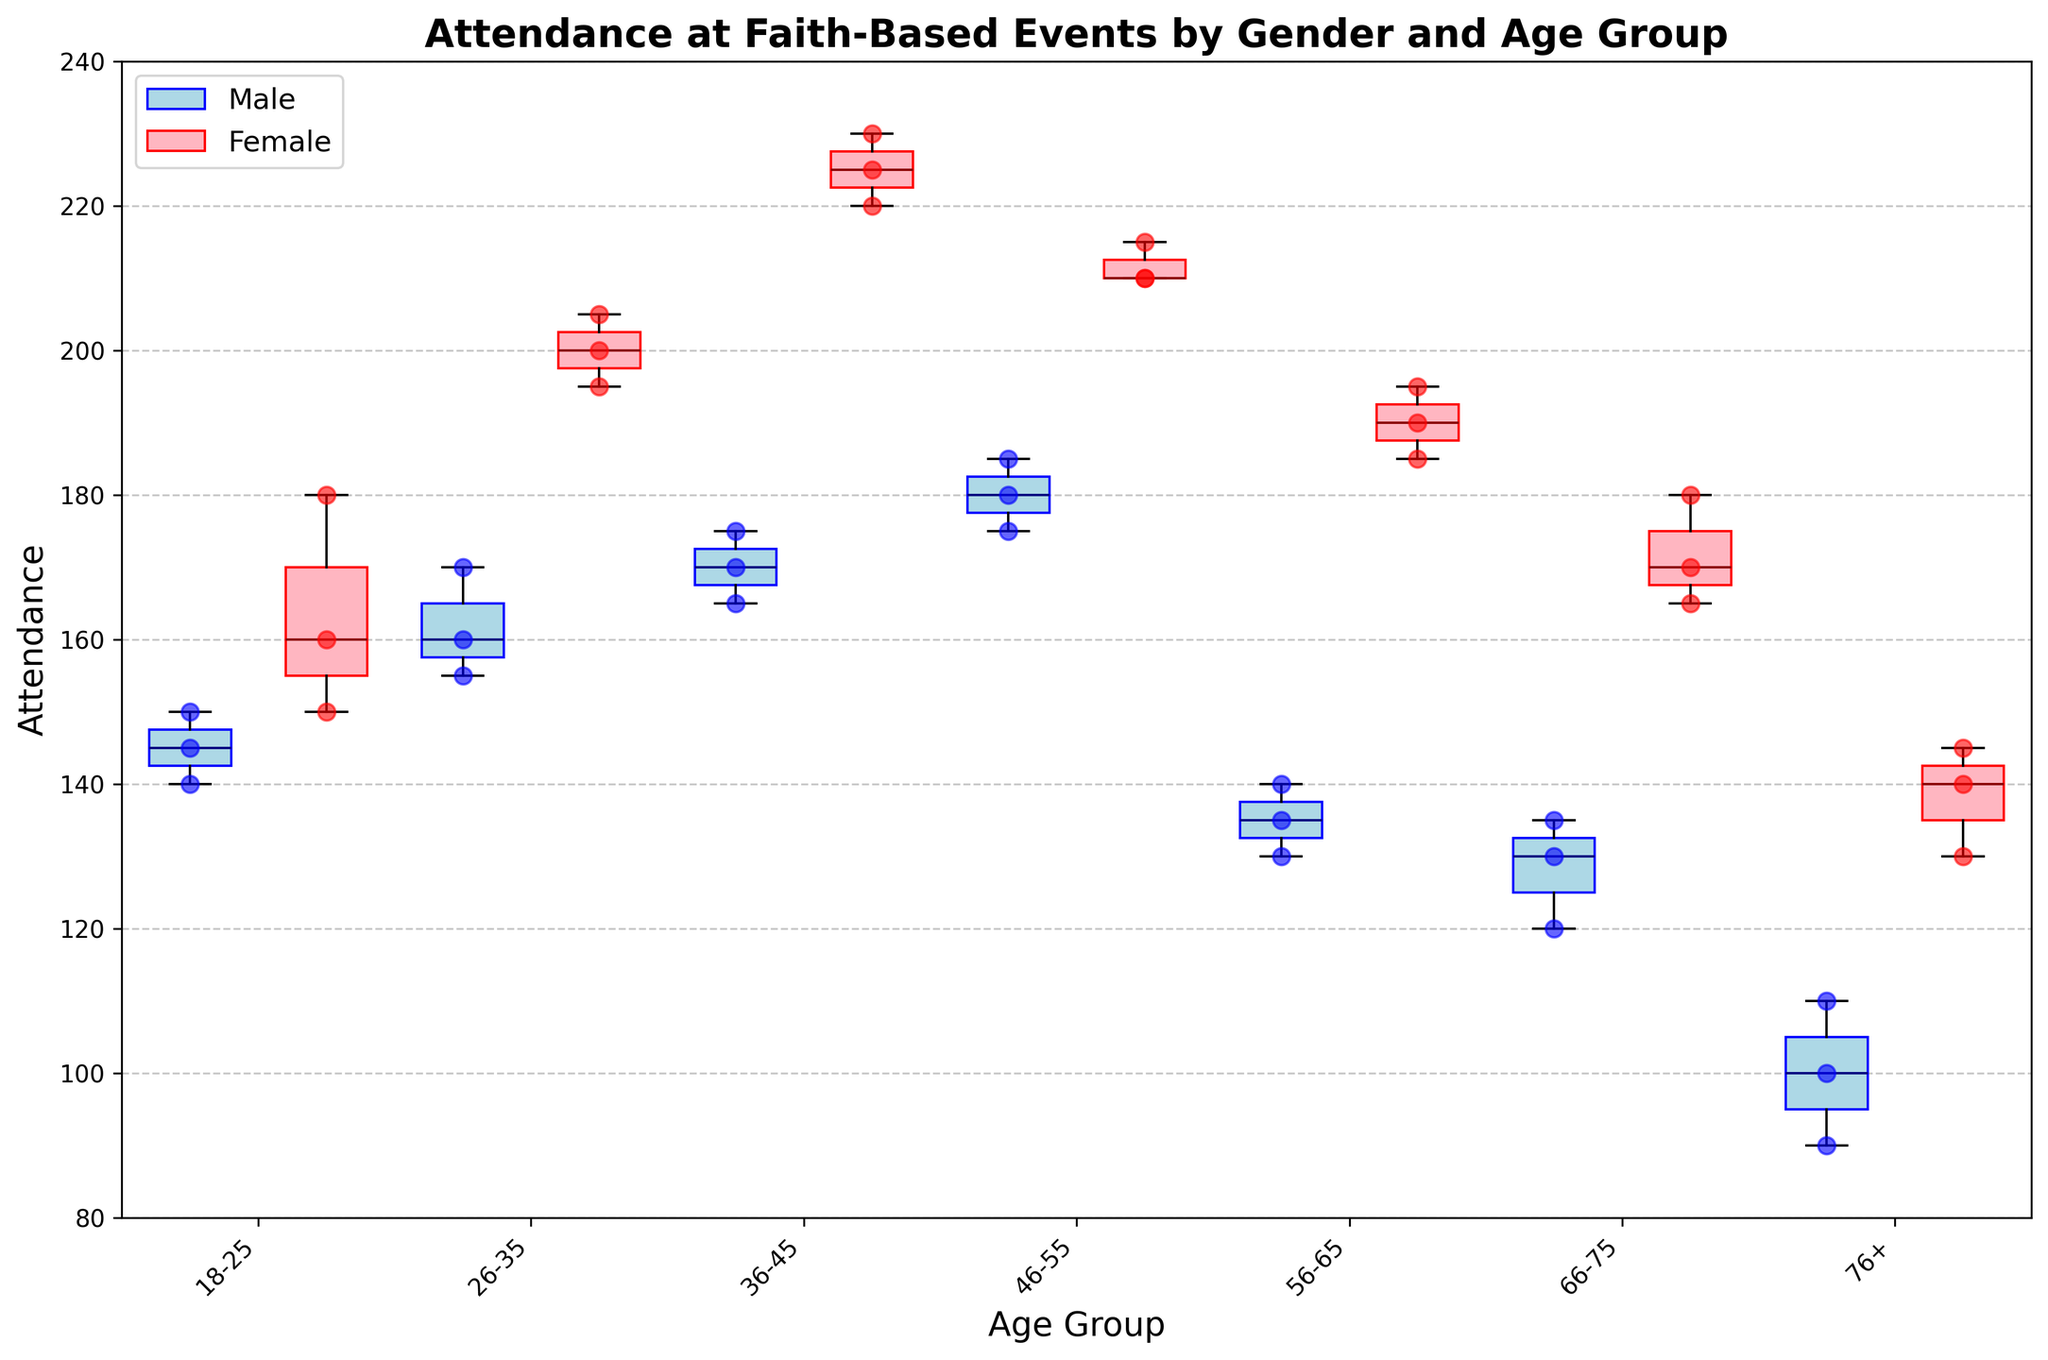What's the title of the plot? The title is usually displayed at the top of the plot. In this case, it's written as "Attendance at Faith-Based Events by Gender and Age Group".
Answer: Attendance at Faith-Based Events by Gender and Age Group What are the labels on the x-axis and y-axis? The labels for the axes are usually placed alongside the respective axes. The x-axis would have "Age Group" and the y-axis would have "Attendance".
Answer: Age Group (x-axis), Attendance (y-axis) What age group has the highest attendance median for males? To find the median, look for the line inside each box plot for males, which are in blue. The age group 46-55 has the highest median line compared to other age groups for males.
Answer: 46-55 Which gender shows higher attendance in the 36-45 age group? Compare the position of the medians (lines inside the boxes) for both males and females in the 36-45 age group. The female median, marked in dark red, is higher than the male median, which is in navy blue.
Answer: Female Which age group has the widest range of attendance for females? The range can be judged by the length of the box plots. For females, the 36-45 age group's box plot is the widest, indicating a larger range.
Answer: 36-45 How does the attendance trend change for males as they age? Look at the medians for males across the age groups from youngest to oldest. The median values generally start higher and decrease with age, indicating a downward trend.
Answer: Decreases as they age Is there any age group where the attendance for males and females overlaps significantly? This can be seen if the box plots of males and females in any age groups are positioned closely. The age group 56-65 shows significant overlap in their attendance ranges.
Answer: 56-65 What age group has the most consistent attendance for females? The consistency can be judged by the shortest box plot. For females, the age group 18-25 has the shortest box plot, indicating the most consistent attendance.
Answer: 18-25 Whether any outliers present for females in the 76+ age group? Look for any points outside the whiskers of the box plots. For females in the 76+ age group, there are no points outside which indicates no outliers.
Answer: No What are the colors used to represent males and females in the plots? The box colors for males are light blue with navy medians and for females are light pink with dark red medians. Scatter points follow similar color coding.
Answer: Light blue and navy for males, light pink and dark red for females 